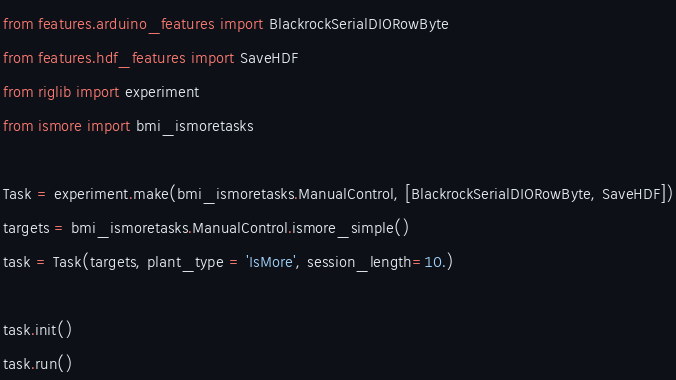<code> <loc_0><loc_0><loc_500><loc_500><_Python_>from features.arduino_features import BlackrockSerialDIORowByte
from features.hdf_features import SaveHDF
from riglib import experiment
from ismore import bmi_ismoretasks 

Task = experiment.make(bmi_ismoretasks.ManualControl, [BlackrockSerialDIORowByte, SaveHDF])
targets = bmi_ismoretasks.ManualControl.ismore_simple()
task = Task(targets, plant_type = 'IsMore', session_length=10.)

task.init()
task.run()</code> 